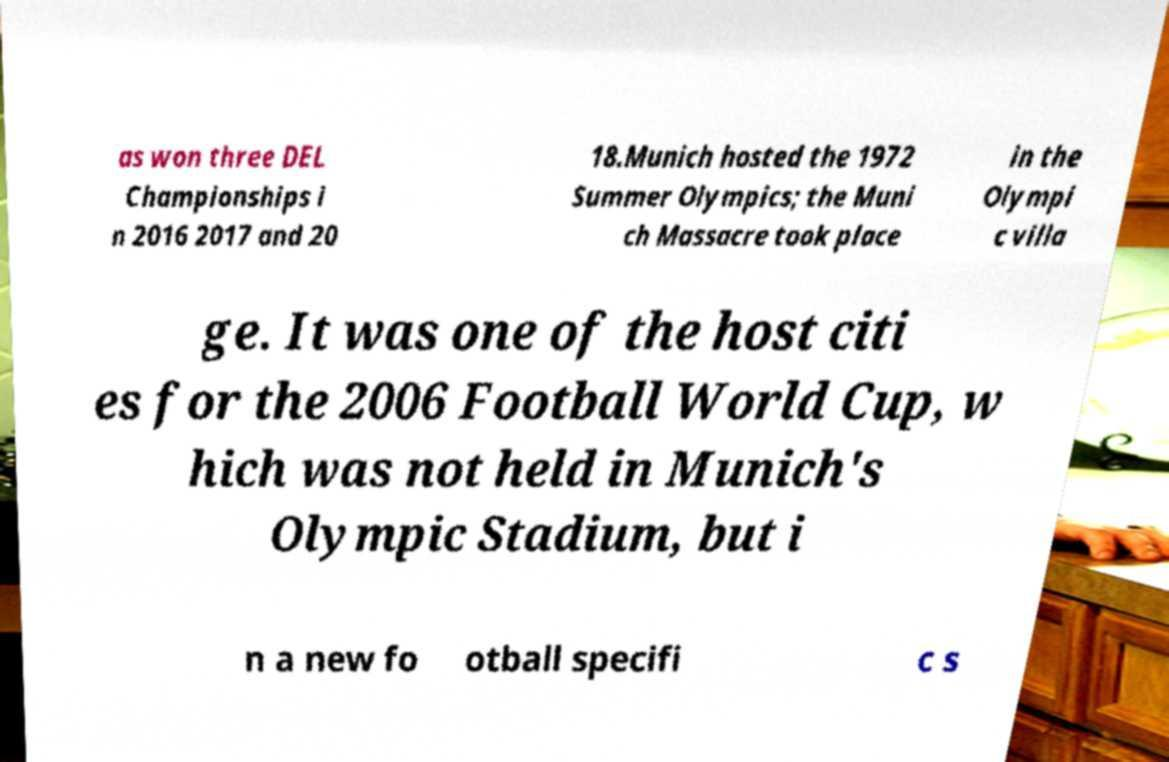Please read and relay the text visible in this image. What does it say? as won three DEL Championships i n 2016 2017 and 20 18.Munich hosted the 1972 Summer Olympics; the Muni ch Massacre took place in the Olympi c villa ge. It was one of the host citi es for the 2006 Football World Cup, w hich was not held in Munich's Olympic Stadium, but i n a new fo otball specifi c s 